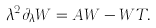Convert formula to latex. <formula><loc_0><loc_0><loc_500><loc_500>\lambda ^ { 2 } \partial _ { \lambda } W = A W - W T .</formula> 